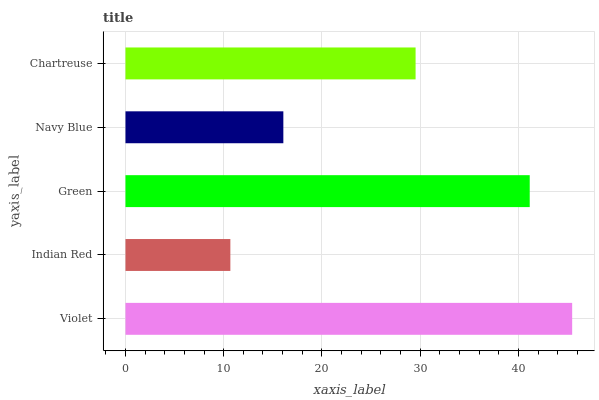Is Indian Red the minimum?
Answer yes or no. Yes. Is Violet the maximum?
Answer yes or no. Yes. Is Green the minimum?
Answer yes or no. No. Is Green the maximum?
Answer yes or no. No. Is Green greater than Indian Red?
Answer yes or no. Yes. Is Indian Red less than Green?
Answer yes or no. Yes. Is Indian Red greater than Green?
Answer yes or no. No. Is Green less than Indian Red?
Answer yes or no. No. Is Chartreuse the high median?
Answer yes or no. Yes. Is Chartreuse the low median?
Answer yes or no. Yes. Is Indian Red the high median?
Answer yes or no. No. Is Navy Blue the low median?
Answer yes or no. No. 